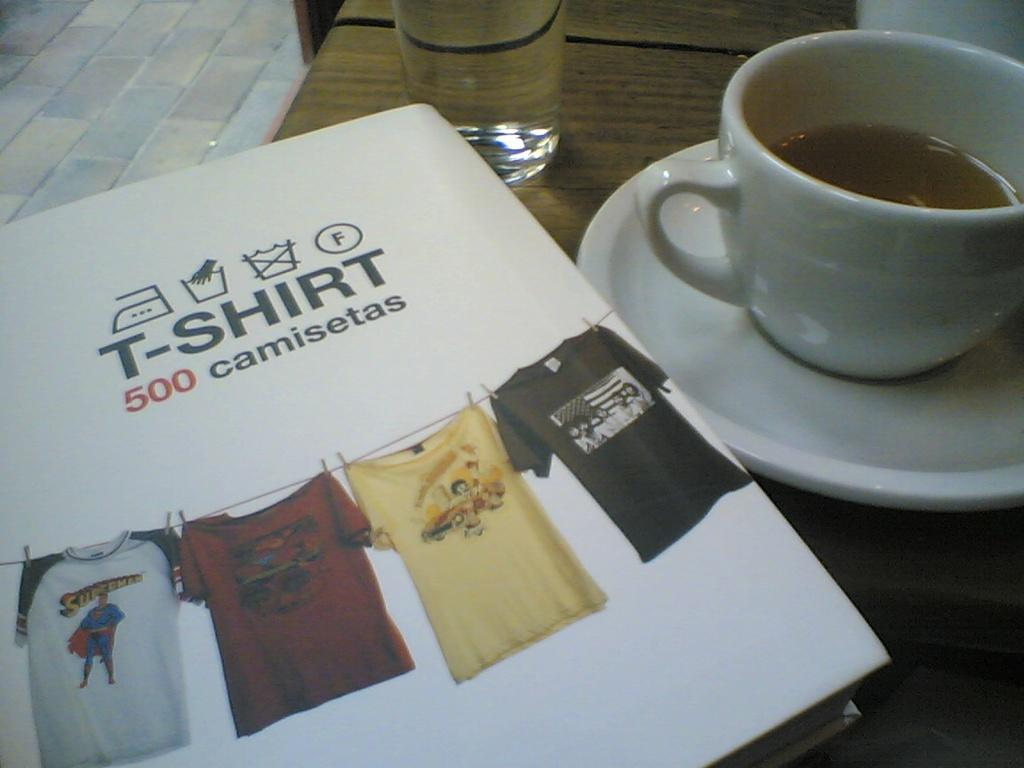<image>
Summarize the visual content of the image. A book titled " T Shirt 500 Camisetas" that have shirts on the cover. 